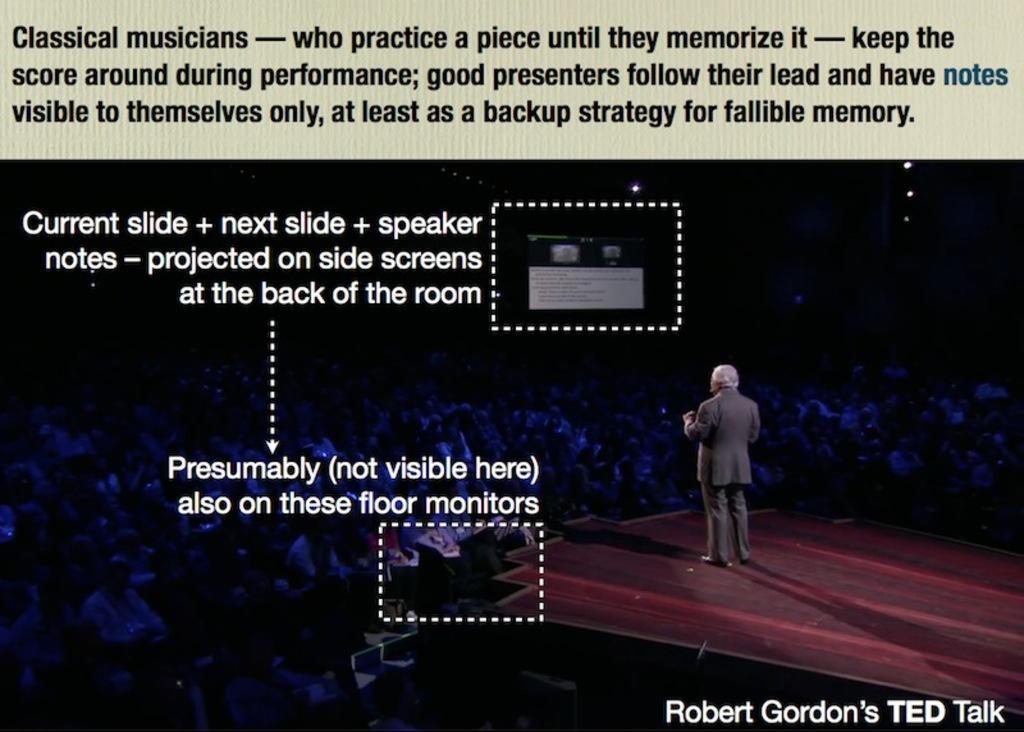Please provide a concise description of this image. This image consists of a poster. In which there are many persons sitting. To the right, there is a man wearing suit is talking on the dais. To the left, there is a text. 